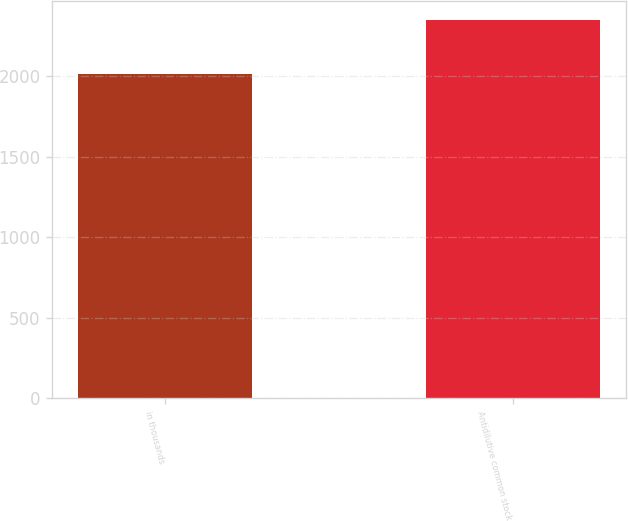Convert chart to OTSL. <chart><loc_0><loc_0><loc_500><loc_500><bar_chart><fcel>in thousands<fcel>Antidilutive common stock<nl><fcel>2014<fcel>2352<nl></chart> 